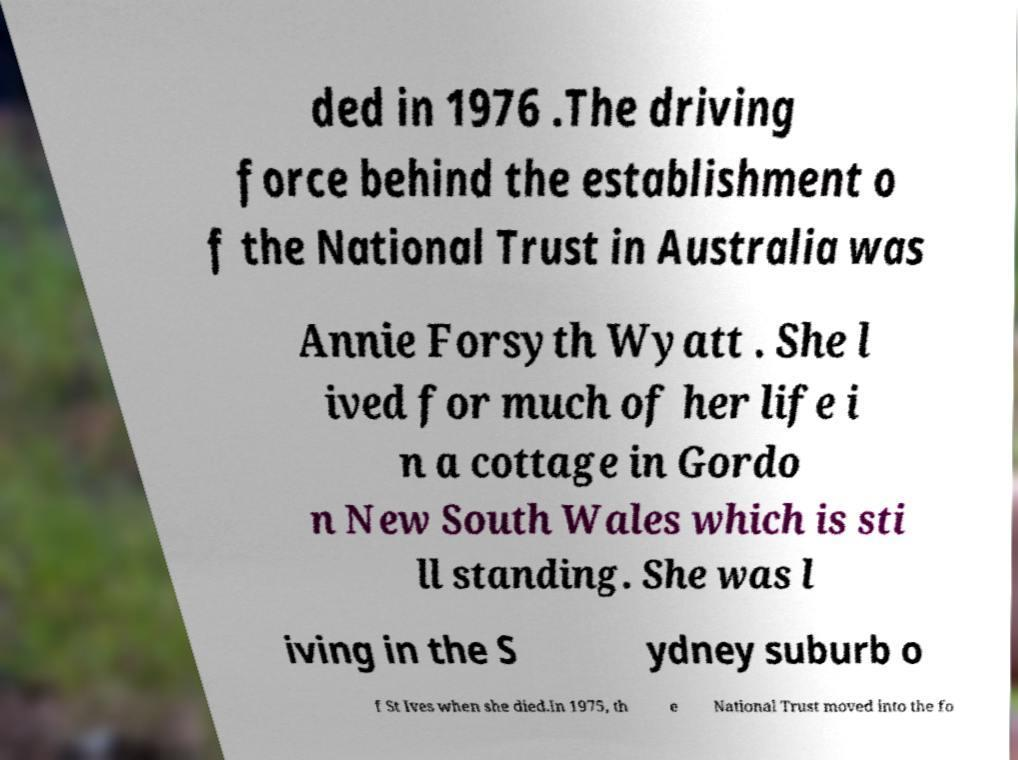Please identify and transcribe the text found in this image. ded in 1976 .The driving force behind the establishment o f the National Trust in Australia was Annie Forsyth Wyatt . She l ived for much of her life i n a cottage in Gordo n New South Wales which is sti ll standing. She was l iving in the S ydney suburb o f St Ives when she died.In 1975, th e National Trust moved into the fo 